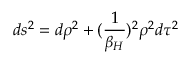<formula> <loc_0><loc_0><loc_500><loc_500>d s ^ { 2 } = d \rho ^ { 2 } + ( { \frac { 1 } { \beta _ { H } } } ) ^ { 2 } \rho ^ { 2 } d \tau ^ { 2 }</formula> 